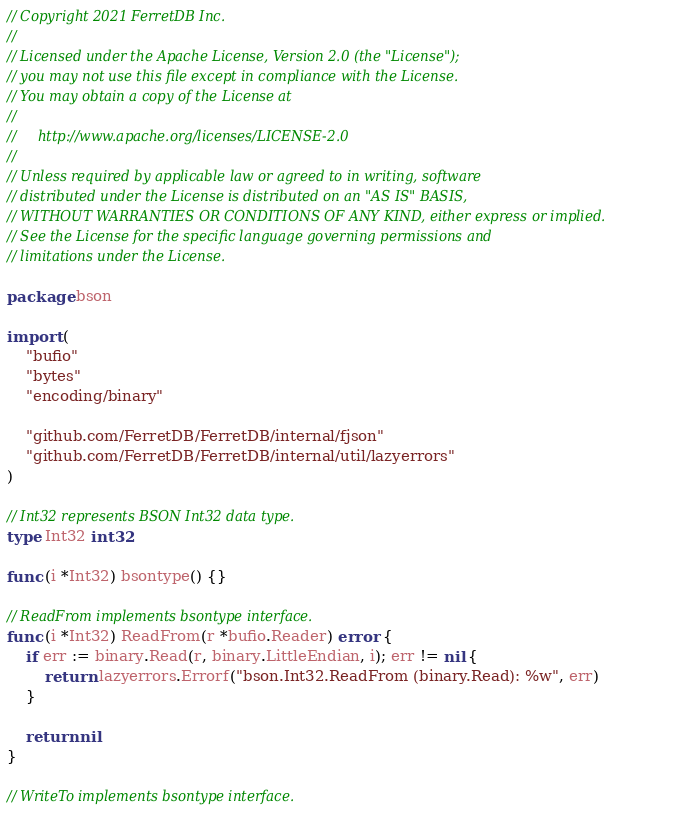<code> <loc_0><loc_0><loc_500><loc_500><_Go_>// Copyright 2021 FerretDB Inc.
//
// Licensed under the Apache License, Version 2.0 (the "License");
// you may not use this file except in compliance with the License.
// You may obtain a copy of the License at
//
//     http://www.apache.org/licenses/LICENSE-2.0
//
// Unless required by applicable law or agreed to in writing, software
// distributed under the License is distributed on an "AS IS" BASIS,
// WITHOUT WARRANTIES OR CONDITIONS OF ANY KIND, either express or implied.
// See the License for the specific language governing permissions and
// limitations under the License.

package bson

import (
	"bufio"
	"bytes"
	"encoding/binary"

	"github.com/FerretDB/FerretDB/internal/fjson"
	"github.com/FerretDB/FerretDB/internal/util/lazyerrors"
)

// Int32 represents BSON Int32 data type.
type Int32 int32

func (i *Int32) bsontype() {}

// ReadFrom implements bsontype interface.
func (i *Int32) ReadFrom(r *bufio.Reader) error {
	if err := binary.Read(r, binary.LittleEndian, i); err != nil {
		return lazyerrors.Errorf("bson.Int32.ReadFrom (binary.Read): %w", err)
	}

	return nil
}

// WriteTo implements bsontype interface.</code> 